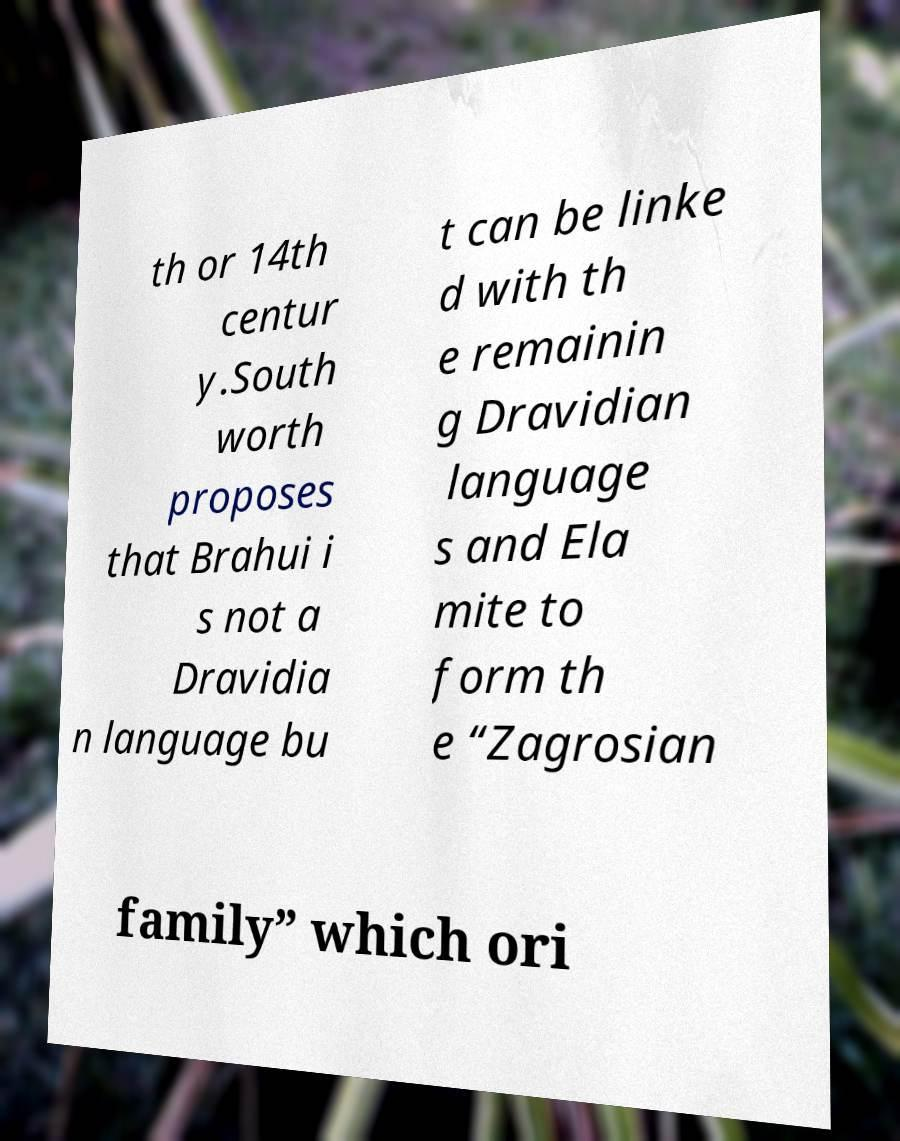I need the written content from this picture converted into text. Can you do that? th or 14th centur y.South worth proposes that Brahui i s not a Dravidia n language bu t can be linke d with th e remainin g Dravidian language s and Ela mite to form th e “Zagrosian family” which ori 